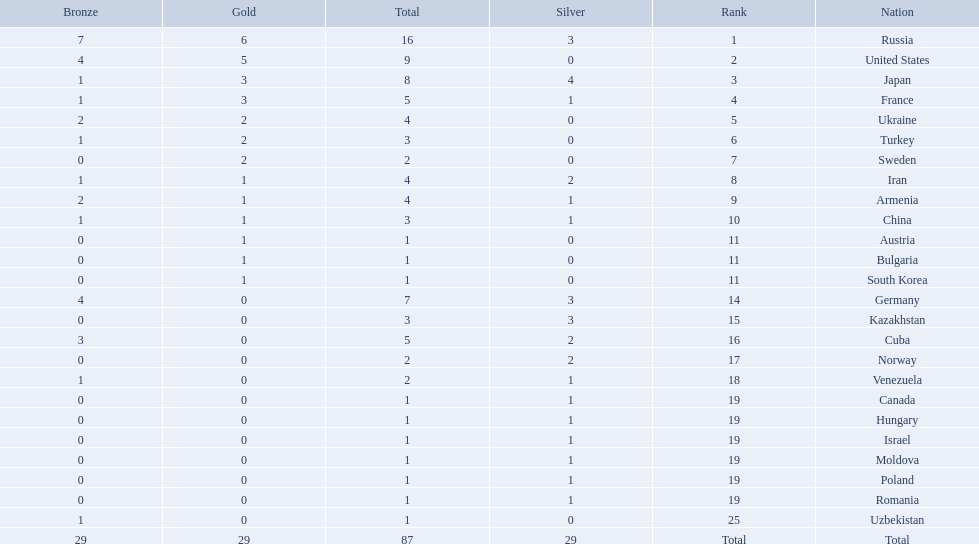Which countries competed in the 1995 world wrestling championships? Russia, United States, Japan, France, Ukraine, Turkey, Sweden, Iran, Armenia, China, Austria, Bulgaria, South Korea, Germany, Kazakhstan, Cuba, Norway, Venezuela, Canada, Hungary, Israel, Moldova, Poland, Romania, Uzbekistan. What country won only one medal? Austria, Bulgaria, South Korea, Canada, Hungary, Israel, Moldova, Poland, Romania, Uzbekistan. Which of these won a bronze medal? Uzbekistan. 